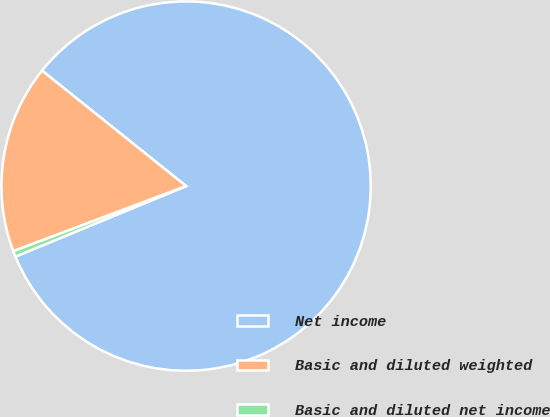<chart> <loc_0><loc_0><loc_500><loc_500><pie_chart><fcel>Net income<fcel>Basic and diluted weighted<fcel>Basic and diluted net income<nl><fcel>83.02%<fcel>16.49%<fcel>0.5%<nl></chart> 